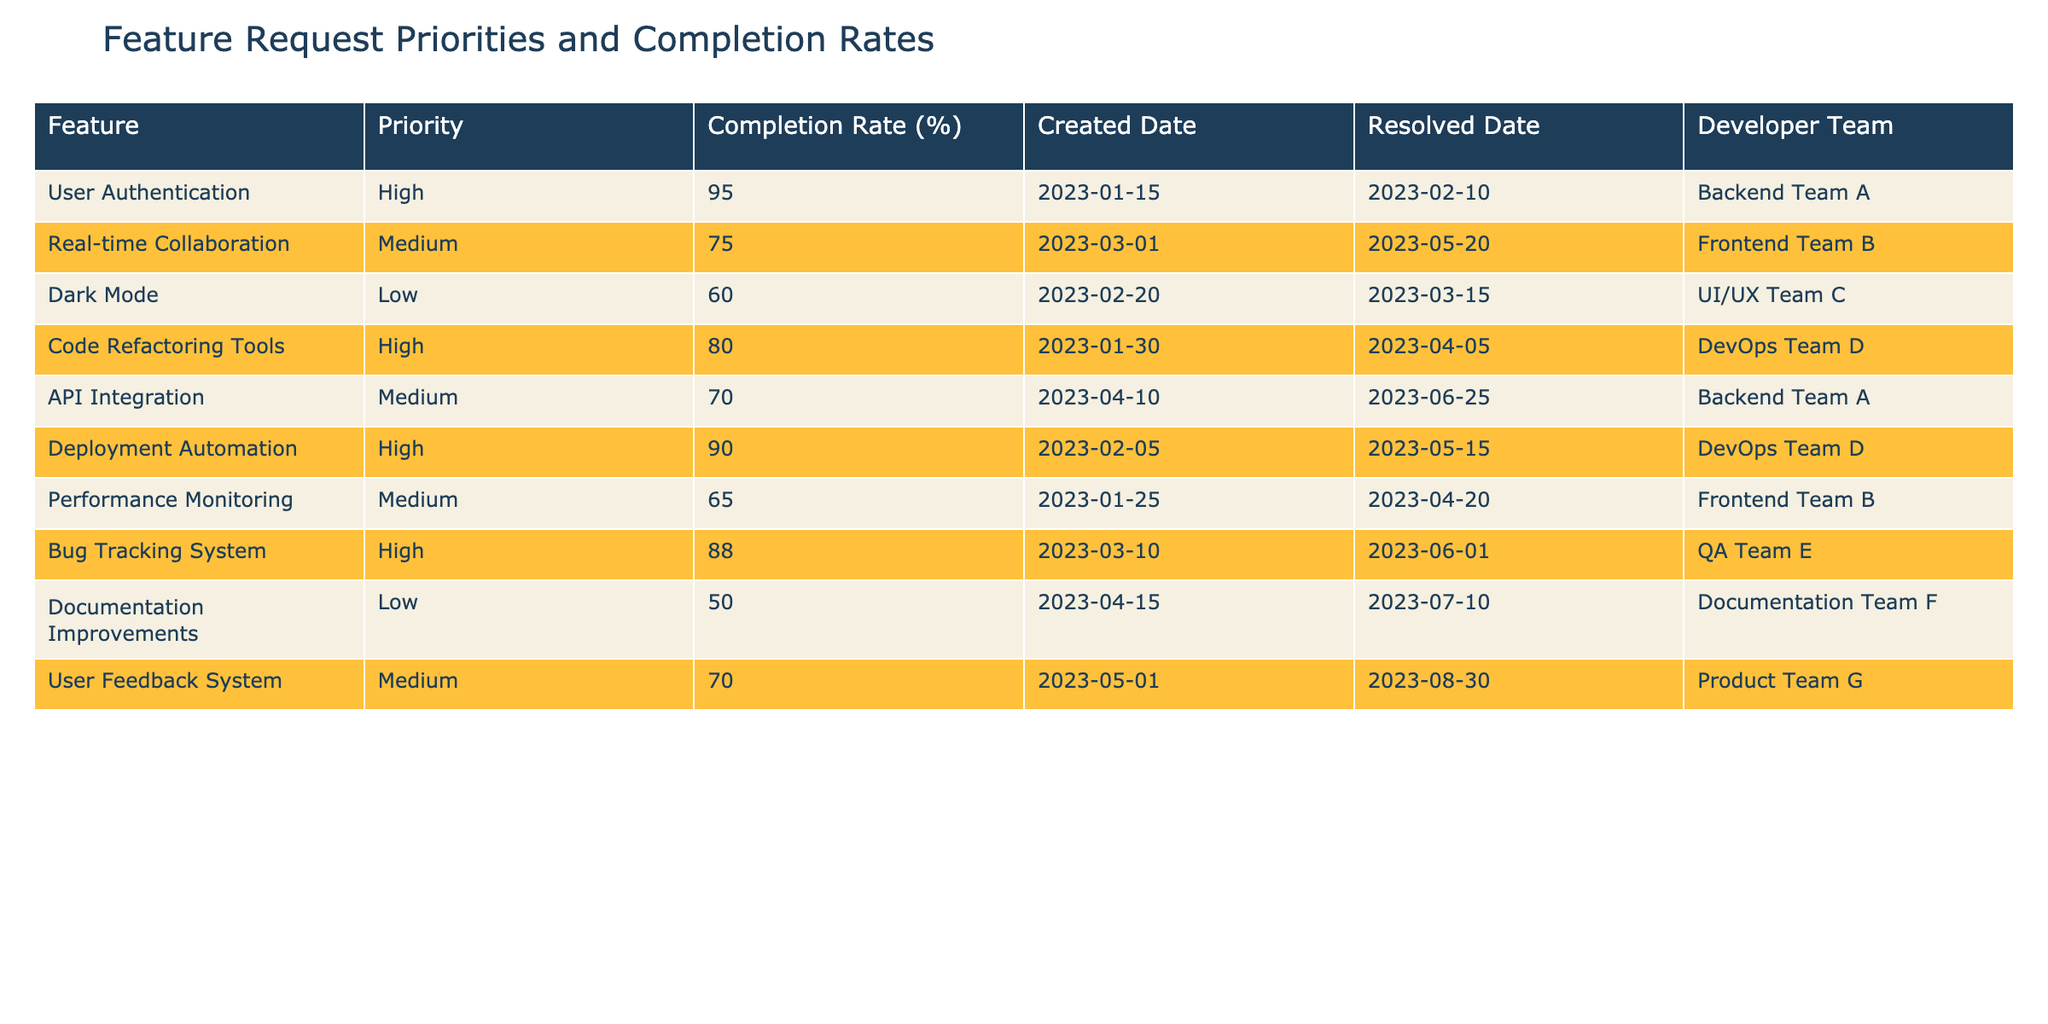What is the completion rate of the User Authentication feature? The feature User Authentication has a completion rate listed in the table. By locating the row for User Authentication, we see the value in the Completion Rate (%) column is 95.
Answer: 95 Which feature has the lowest completion rate? To find the feature with the lowest completion rate, we can compare the values in the Completion Rate (%) column. The lowest value is 50, associated with the Documentation Improvements feature, making it the one with the lowest completion rate.
Answer: Documentation Improvements How many features have a high priority? The features that are labeled as High in the Priority column can be counted. They are User Authentication, Code Refactoring Tools, Deployment Automation, and Bug Tracking System, totaling four features.
Answer: 4 What is the average completion rate of the features with medium priority? The features with medium priority are Real-time Collaboration, API Integration, Performance Monitoring, and User Feedback System, with completion rates of 75, 70, 65, and 70 respectively. Summing these gives 75 + 70 + 65 + 70 = 280, then dividing by the number of features (4) gives an average of 280/4 = 70.
Answer: 70 Is there any feature that was completed earlier than March 10, 2023? Checking the Resolved Date column, we find that User Authentication and Code Refactoring Tools were completed before March 10, 2023, as their resolved dates are February 10, 2023, and April 5, 2023, respectively. Hence, the answer is yes.
Answer: Yes Which developer team completed the Deployment Automation feature? This information can be found in the Developer Team column by looking at the corresponding row for Deployment Automation where the team identified is DevOps Team D.
Answer: DevOps Team D What is the percentage difference in completion rates between the highest and lowest priority features? First, the highest completion rate is 95 (User Authentication), and the lowest is 50 (Documentation Improvements). The difference is 95 - 50 = 45. Dividing by the highest completion rate gives (45/95) * 100 which is approximately 47.37%.
Answer: 47.37% Among all features, which one took the longest time to resolve? To determine this, we need to calculate the number of days between the Created Date and the Resolved Date for each feature. After calculating, we find that the Real-time Collaboration feature took the longest, resolving on May 20, 2023, from its creation on March 1, 2023, resulting in 80 days.
Answer: Real-time Collaboration Did any features developed by the Backend Team have a medium priority? By examining the Developer Team and Priority columns, we find that API Integration with a medium priority is developed by Backend Team A. Thus, it confirms that there is at least one feature from that team with medium priority.
Answer: Yes 